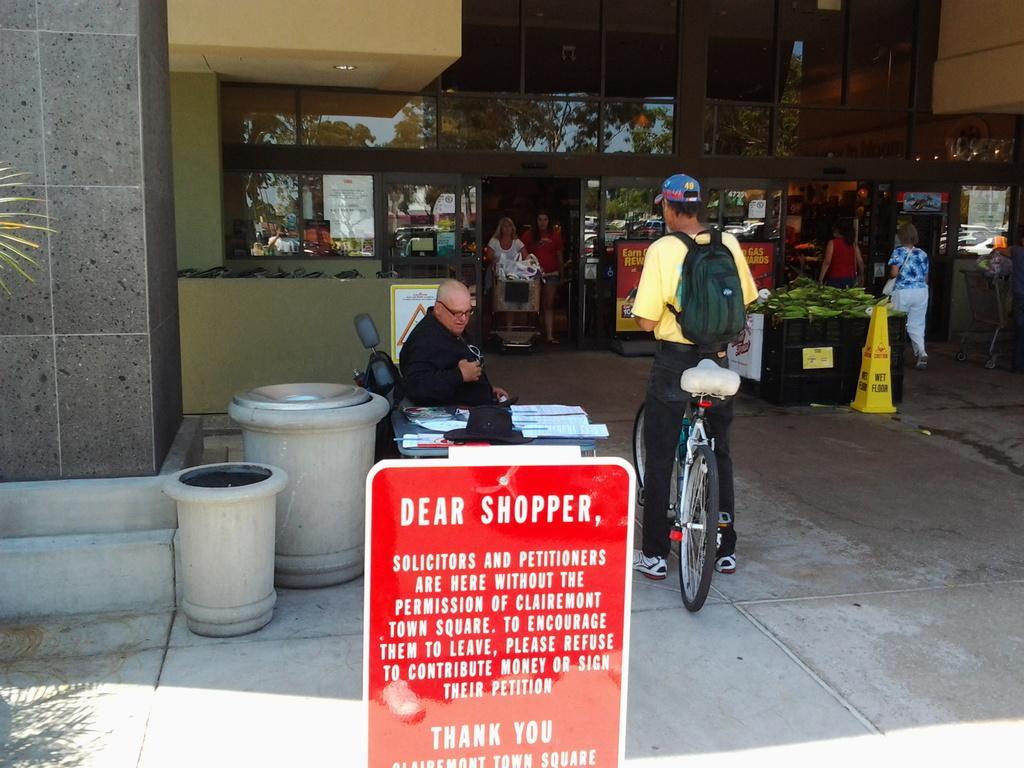Describe this image in one or two sentences. In this image, In the middle there is a board which is red color, In the right side there is a man standing on the bicycle, There is a man sitting on the chair, In the background there is a black color table and yellow color stand, There is a yellow color wall, In the left side there is a black color wall. 